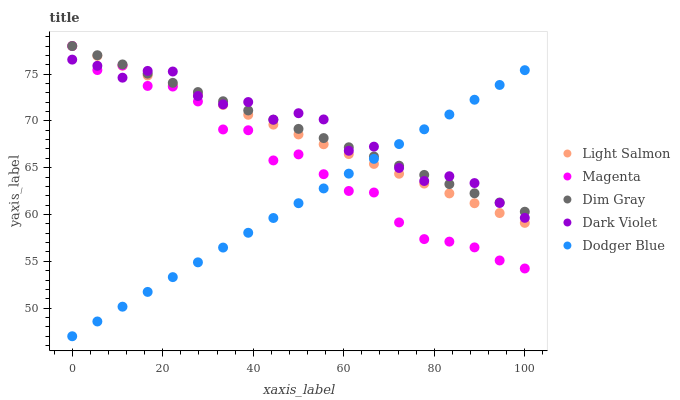Does Dodger Blue have the minimum area under the curve?
Answer yes or no. Yes. Does Dark Violet have the maximum area under the curve?
Answer yes or no. Yes. Does Dim Gray have the minimum area under the curve?
Answer yes or no. No. Does Dim Gray have the maximum area under the curve?
Answer yes or no. No. Is Dodger Blue the smoothest?
Answer yes or no. Yes. Is Magenta the roughest?
Answer yes or no. Yes. Is Dim Gray the smoothest?
Answer yes or no. No. Is Dim Gray the roughest?
Answer yes or no. No. Does Dodger Blue have the lowest value?
Answer yes or no. Yes. Does Dim Gray have the lowest value?
Answer yes or no. No. Does Magenta have the highest value?
Answer yes or no. Yes. Does Dodger Blue have the highest value?
Answer yes or no. No. Does Dodger Blue intersect Light Salmon?
Answer yes or no. Yes. Is Dodger Blue less than Light Salmon?
Answer yes or no. No. Is Dodger Blue greater than Light Salmon?
Answer yes or no. No. 